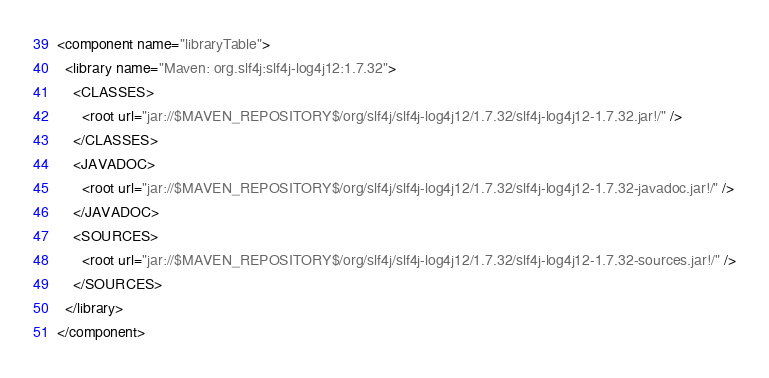Convert code to text. <code><loc_0><loc_0><loc_500><loc_500><_XML_><component name="libraryTable">
  <library name="Maven: org.slf4j:slf4j-log4j12:1.7.32">
    <CLASSES>
      <root url="jar://$MAVEN_REPOSITORY$/org/slf4j/slf4j-log4j12/1.7.32/slf4j-log4j12-1.7.32.jar!/" />
    </CLASSES>
    <JAVADOC>
      <root url="jar://$MAVEN_REPOSITORY$/org/slf4j/slf4j-log4j12/1.7.32/slf4j-log4j12-1.7.32-javadoc.jar!/" />
    </JAVADOC>
    <SOURCES>
      <root url="jar://$MAVEN_REPOSITORY$/org/slf4j/slf4j-log4j12/1.7.32/slf4j-log4j12-1.7.32-sources.jar!/" />
    </SOURCES>
  </library>
</component></code> 